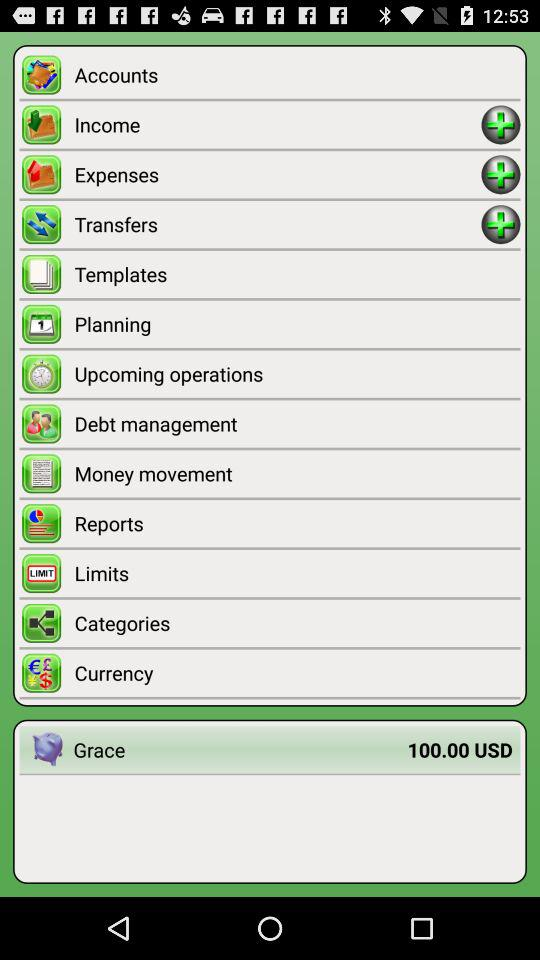How much money does Grace have?
Answer the question using a single word or phrase. 100.00 USD 